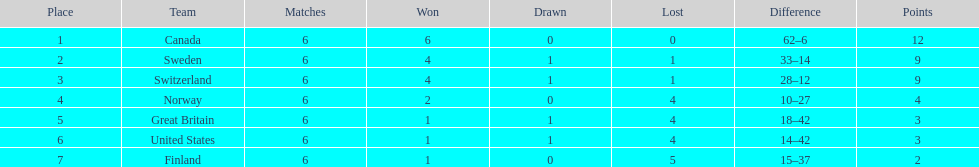Which team came subsequent to sweden? Switzerland. 